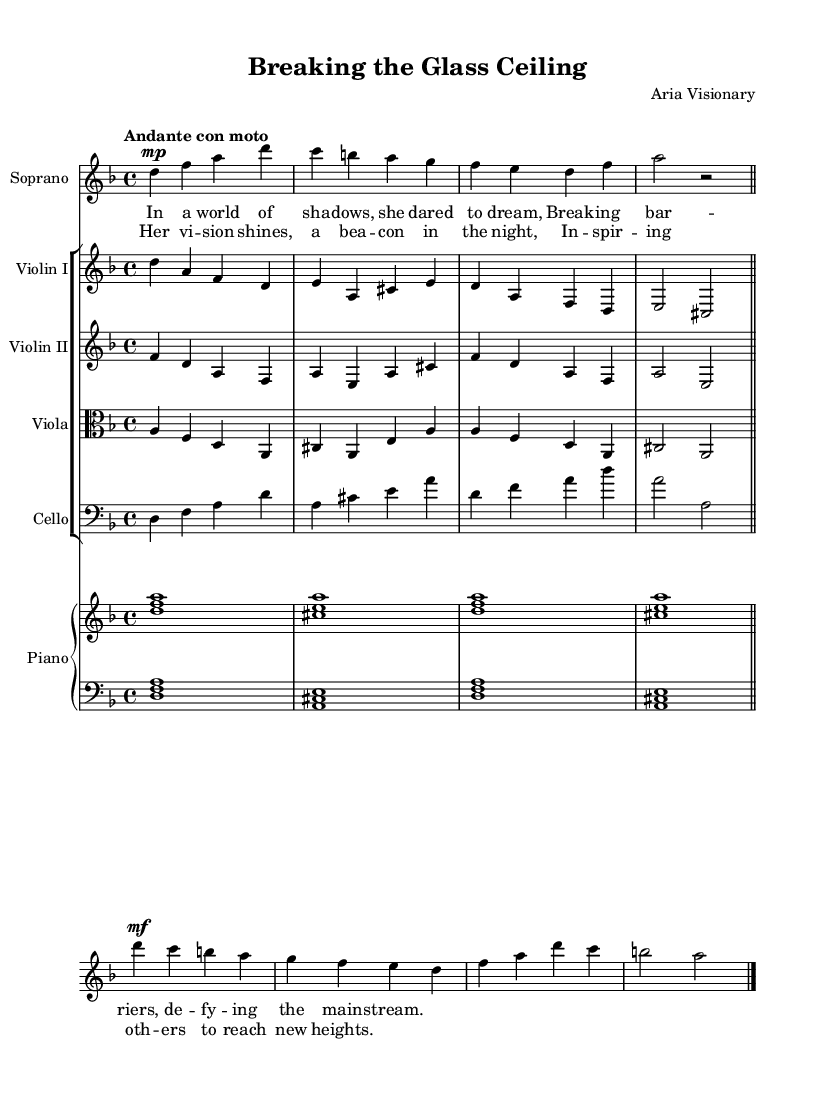What is the key signature of this music? The key signature is determined by the number of sharps or flats at the beginning of the staff. In this case, the music is in D minor, which has one flat (B flat).
Answer: D minor What is the time signature of the piece? The time signature is found at the beginning of the staff, typically right after the key signature. Here, it is 4/4, indicating four beats per measure.
Answer: 4/4 What tempo marking is indicated in the music? The tempo marking appears at the beginning of the piece, indicating how fast or slow the music should be played. This is marked "Andante con moto."
Answer: Andante con moto How many vocal lines are present in this score? The score shows a designated staff for each part, and a staff labeled "Soprano" indicates the presence of a single vocal line for the soprano.
Answer: 1 What is the main theme of the lyrics as indicated in the verse? The lyrics in the verse speak to themes of defiance and breaking barriers, suggesting a narrative or emotional journey that highlights overcoming obstacles.
Answer: Breaking barriers What instruments are featured in the orchestration? The orchestration can be identified by the different staves labeled for each instrument. Instruments such as violin, viola, cello, and piano can be found within the score.
Answer: Violin, Viola, Cello, Piano What musical form can be identified in the arrangement of the score? The arrangement shows distinct sections such as verses and choruses, with repeated ideas typically seen in operatic works, creating a verse-chorus structure.
Answer: Verse-Chorus 